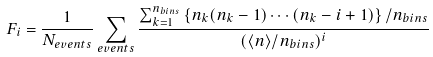<formula> <loc_0><loc_0><loc_500><loc_500>F _ { i } = \frac { 1 } { N _ { e v e n t s } } \sum _ { e v e n t s } \frac { \sum _ { k = 1 } ^ { n _ { b i n s } } \left \{ n _ { k } ( n _ { k } - 1 ) \cdots ( n _ { k } - i + 1 ) \right \} / n _ { b i n s } } { ( \langle n \rangle / n _ { b i n s } ) ^ { i } }</formula> 